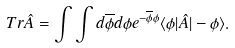Convert formula to latex. <formula><loc_0><loc_0><loc_500><loc_500>T r \hat { A } = \int \int d \overline { \phi } d \phi e ^ { - \overline { \phi } \phi } \langle \phi | \hat { A } | - \phi \rangle .</formula> 